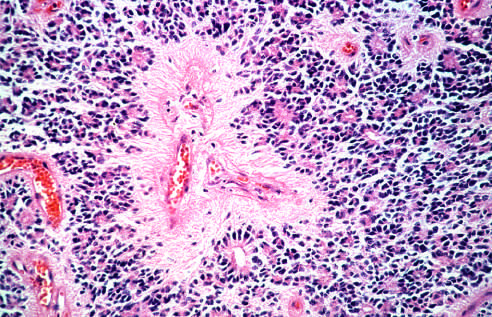how do tumor cells have round nuclei?
Answer the question using a single word or phrase. Often with a clear cytoplasmic halo 